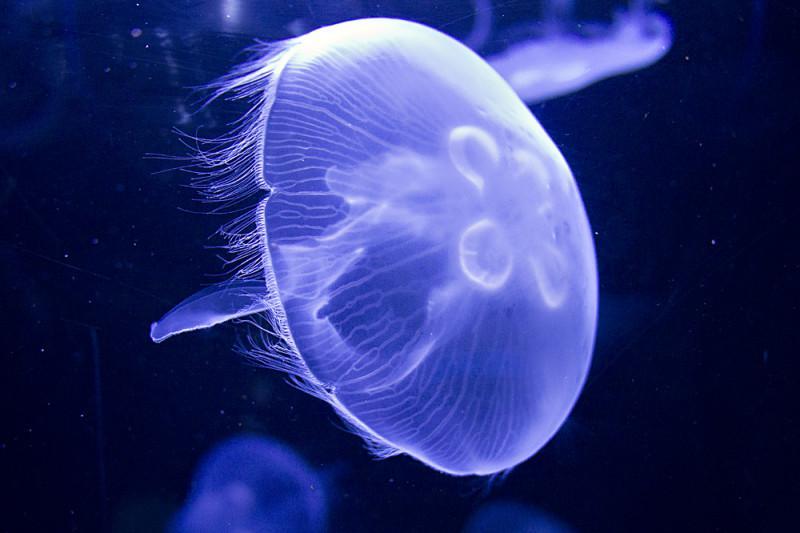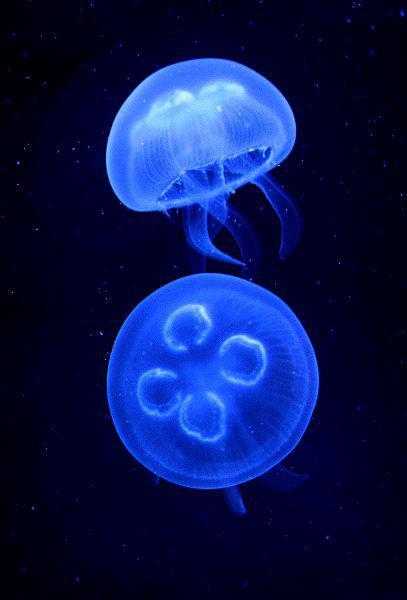The first image is the image on the left, the second image is the image on the right. Examine the images to the left and right. Is the description "Each image includes one jellyfish viewed with its """"cap"""" head-on, showing something that resembles a neon-lit four-leaf clover." accurate? Answer yes or no. No. The first image is the image on the left, the second image is the image on the right. For the images displayed, is the sentence "At least one of the images has a purple tint to it; not just blue with tinges of orange." factually correct? Answer yes or no. Yes. 